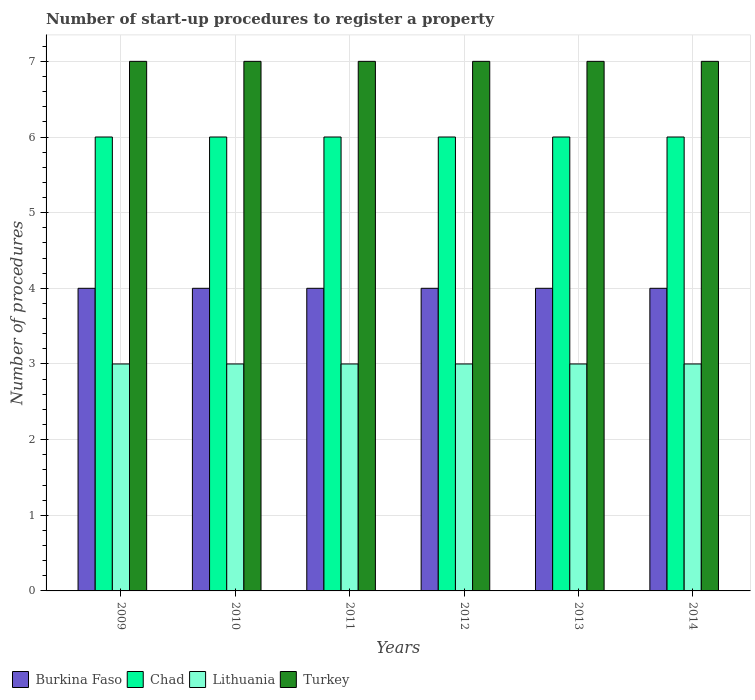How many different coloured bars are there?
Your answer should be very brief. 4. How many bars are there on the 4th tick from the left?
Ensure brevity in your answer.  4. What is the label of the 1st group of bars from the left?
Your answer should be very brief. 2009. What is the number of procedures required to register a property in Turkey in 2010?
Your answer should be very brief. 7. Across all years, what is the minimum number of procedures required to register a property in Lithuania?
Give a very brief answer. 3. What is the total number of procedures required to register a property in Lithuania in the graph?
Ensure brevity in your answer.  18. What is the difference between the number of procedures required to register a property in Turkey in 2011 and the number of procedures required to register a property in Lithuania in 2012?
Your answer should be compact. 4. In the year 2010, what is the difference between the number of procedures required to register a property in Turkey and number of procedures required to register a property in Lithuania?
Offer a terse response. 4. In how many years, is the number of procedures required to register a property in Burkina Faso greater than 5.6?
Your response must be concise. 0. Is the difference between the number of procedures required to register a property in Turkey in 2010 and 2011 greater than the difference between the number of procedures required to register a property in Lithuania in 2010 and 2011?
Your answer should be compact. No. What is the difference between the highest and the lowest number of procedures required to register a property in Lithuania?
Give a very brief answer. 0. Is the sum of the number of procedures required to register a property in Burkina Faso in 2009 and 2012 greater than the maximum number of procedures required to register a property in Chad across all years?
Provide a short and direct response. Yes. What does the 3rd bar from the left in 2009 represents?
Keep it short and to the point. Lithuania. What does the 4th bar from the right in 2012 represents?
Provide a succinct answer. Burkina Faso. Are all the bars in the graph horizontal?
Your answer should be very brief. No. How many years are there in the graph?
Provide a short and direct response. 6. What is the difference between two consecutive major ticks on the Y-axis?
Your answer should be very brief. 1. Does the graph contain any zero values?
Ensure brevity in your answer.  No. Does the graph contain grids?
Keep it short and to the point. Yes. How many legend labels are there?
Provide a short and direct response. 4. What is the title of the graph?
Provide a succinct answer. Number of start-up procedures to register a property. What is the label or title of the Y-axis?
Provide a succinct answer. Number of procedures. What is the Number of procedures in Burkina Faso in 2009?
Offer a very short reply. 4. What is the Number of procedures of Lithuania in 2009?
Your answer should be very brief. 3. What is the Number of procedures in Turkey in 2009?
Provide a short and direct response. 7. What is the Number of procedures in Burkina Faso in 2010?
Provide a succinct answer. 4. What is the Number of procedures of Chad in 2010?
Offer a very short reply. 6. What is the Number of procedures in Burkina Faso in 2011?
Offer a very short reply. 4. What is the Number of procedures of Lithuania in 2011?
Offer a very short reply. 3. What is the Number of procedures of Burkina Faso in 2012?
Your answer should be compact. 4. What is the Number of procedures of Turkey in 2012?
Offer a terse response. 7. What is the Number of procedures in Burkina Faso in 2014?
Make the answer very short. 4. What is the Number of procedures of Turkey in 2014?
Provide a short and direct response. 7. Across all years, what is the maximum Number of procedures in Lithuania?
Provide a succinct answer. 3. Across all years, what is the minimum Number of procedures of Burkina Faso?
Your response must be concise. 4. Across all years, what is the minimum Number of procedures of Lithuania?
Your answer should be very brief. 3. What is the total Number of procedures in Burkina Faso in the graph?
Provide a succinct answer. 24. What is the total Number of procedures of Chad in the graph?
Offer a very short reply. 36. What is the difference between the Number of procedures of Chad in 2009 and that in 2010?
Provide a short and direct response. 0. What is the difference between the Number of procedures of Burkina Faso in 2009 and that in 2011?
Give a very brief answer. 0. What is the difference between the Number of procedures in Chad in 2009 and that in 2011?
Offer a terse response. 0. What is the difference between the Number of procedures in Lithuania in 2009 and that in 2011?
Offer a terse response. 0. What is the difference between the Number of procedures in Turkey in 2009 and that in 2011?
Your answer should be very brief. 0. What is the difference between the Number of procedures in Lithuania in 2009 and that in 2012?
Your response must be concise. 0. What is the difference between the Number of procedures of Turkey in 2009 and that in 2012?
Keep it short and to the point. 0. What is the difference between the Number of procedures in Lithuania in 2009 and that in 2013?
Keep it short and to the point. 0. What is the difference between the Number of procedures of Turkey in 2009 and that in 2013?
Ensure brevity in your answer.  0. What is the difference between the Number of procedures of Burkina Faso in 2009 and that in 2014?
Offer a terse response. 0. What is the difference between the Number of procedures of Turkey in 2009 and that in 2014?
Keep it short and to the point. 0. What is the difference between the Number of procedures in Burkina Faso in 2010 and that in 2011?
Make the answer very short. 0. What is the difference between the Number of procedures of Lithuania in 2010 and that in 2011?
Your answer should be compact. 0. What is the difference between the Number of procedures of Lithuania in 2010 and that in 2012?
Ensure brevity in your answer.  0. What is the difference between the Number of procedures in Turkey in 2010 and that in 2012?
Your answer should be compact. 0. What is the difference between the Number of procedures in Chad in 2010 and that in 2013?
Provide a short and direct response. 0. What is the difference between the Number of procedures in Chad in 2010 and that in 2014?
Provide a succinct answer. 0. What is the difference between the Number of procedures in Lithuania in 2010 and that in 2014?
Offer a very short reply. 0. What is the difference between the Number of procedures in Chad in 2011 and that in 2012?
Ensure brevity in your answer.  0. What is the difference between the Number of procedures in Lithuania in 2011 and that in 2012?
Make the answer very short. 0. What is the difference between the Number of procedures in Turkey in 2011 and that in 2012?
Offer a terse response. 0. What is the difference between the Number of procedures in Chad in 2011 and that in 2013?
Make the answer very short. 0. What is the difference between the Number of procedures of Lithuania in 2011 and that in 2013?
Provide a succinct answer. 0. What is the difference between the Number of procedures of Turkey in 2011 and that in 2013?
Keep it short and to the point. 0. What is the difference between the Number of procedures of Turkey in 2011 and that in 2014?
Give a very brief answer. 0. What is the difference between the Number of procedures of Burkina Faso in 2012 and that in 2013?
Ensure brevity in your answer.  0. What is the difference between the Number of procedures in Turkey in 2012 and that in 2013?
Keep it short and to the point. 0. What is the difference between the Number of procedures of Burkina Faso in 2012 and that in 2014?
Your response must be concise. 0. What is the difference between the Number of procedures of Chad in 2012 and that in 2014?
Keep it short and to the point. 0. What is the difference between the Number of procedures in Lithuania in 2012 and that in 2014?
Provide a short and direct response. 0. What is the difference between the Number of procedures of Chad in 2013 and that in 2014?
Your answer should be very brief. 0. What is the difference between the Number of procedures of Burkina Faso in 2009 and the Number of procedures of Chad in 2010?
Your answer should be compact. -2. What is the difference between the Number of procedures of Burkina Faso in 2009 and the Number of procedures of Lithuania in 2010?
Your answer should be very brief. 1. What is the difference between the Number of procedures in Burkina Faso in 2009 and the Number of procedures in Turkey in 2010?
Give a very brief answer. -3. What is the difference between the Number of procedures in Chad in 2009 and the Number of procedures in Lithuania in 2010?
Keep it short and to the point. 3. What is the difference between the Number of procedures of Burkina Faso in 2009 and the Number of procedures of Lithuania in 2011?
Make the answer very short. 1. What is the difference between the Number of procedures in Burkina Faso in 2009 and the Number of procedures in Turkey in 2011?
Your response must be concise. -3. What is the difference between the Number of procedures of Chad in 2009 and the Number of procedures of Lithuania in 2011?
Offer a very short reply. 3. What is the difference between the Number of procedures of Chad in 2009 and the Number of procedures of Turkey in 2011?
Keep it short and to the point. -1. What is the difference between the Number of procedures of Lithuania in 2009 and the Number of procedures of Turkey in 2011?
Ensure brevity in your answer.  -4. What is the difference between the Number of procedures of Burkina Faso in 2009 and the Number of procedures of Chad in 2013?
Ensure brevity in your answer.  -2. What is the difference between the Number of procedures of Chad in 2009 and the Number of procedures of Turkey in 2013?
Keep it short and to the point. -1. What is the difference between the Number of procedures in Lithuania in 2009 and the Number of procedures in Turkey in 2013?
Provide a succinct answer. -4. What is the difference between the Number of procedures of Burkina Faso in 2009 and the Number of procedures of Chad in 2014?
Provide a short and direct response. -2. What is the difference between the Number of procedures of Burkina Faso in 2009 and the Number of procedures of Lithuania in 2014?
Your answer should be compact. 1. What is the difference between the Number of procedures of Burkina Faso in 2009 and the Number of procedures of Turkey in 2014?
Keep it short and to the point. -3. What is the difference between the Number of procedures of Chad in 2009 and the Number of procedures of Lithuania in 2014?
Your answer should be very brief. 3. What is the difference between the Number of procedures of Chad in 2009 and the Number of procedures of Turkey in 2014?
Your answer should be very brief. -1. What is the difference between the Number of procedures in Lithuania in 2009 and the Number of procedures in Turkey in 2014?
Offer a terse response. -4. What is the difference between the Number of procedures in Chad in 2010 and the Number of procedures in Lithuania in 2011?
Offer a terse response. 3. What is the difference between the Number of procedures of Burkina Faso in 2010 and the Number of procedures of Chad in 2012?
Offer a very short reply. -2. What is the difference between the Number of procedures in Burkina Faso in 2010 and the Number of procedures in Lithuania in 2012?
Your answer should be compact. 1. What is the difference between the Number of procedures in Burkina Faso in 2010 and the Number of procedures in Turkey in 2012?
Offer a very short reply. -3. What is the difference between the Number of procedures of Chad in 2010 and the Number of procedures of Turkey in 2012?
Make the answer very short. -1. What is the difference between the Number of procedures in Burkina Faso in 2010 and the Number of procedures in Chad in 2013?
Provide a short and direct response. -2. What is the difference between the Number of procedures in Lithuania in 2010 and the Number of procedures in Turkey in 2013?
Your response must be concise. -4. What is the difference between the Number of procedures in Burkina Faso in 2010 and the Number of procedures in Chad in 2014?
Give a very brief answer. -2. What is the difference between the Number of procedures in Burkina Faso in 2010 and the Number of procedures in Turkey in 2014?
Provide a short and direct response. -3. What is the difference between the Number of procedures in Chad in 2010 and the Number of procedures in Lithuania in 2014?
Your response must be concise. 3. What is the difference between the Number of procedures of Chad in 2010 and the Number of procedures of Turkey in 2014?
Offer a terse response. -1. What is the difference between the Number of procedures of Lithuania in 2010 and the Number of procedures of Turkey in 2014?
Provide a short and direct response. -4. What is the difference between the Number of procedures of Chad in 2011 and the Number of procedures of Lithuania in 2012?
Your answer should be compact. 3. What is the difference between the Number of procedures of Lithuania in 2011 and the Number of procedures of Turkey in 2012?
Ensure brevity in your answer.  -4. What is the difference between the Number of procedures in Burkina Faso in 2011 and the Number of procedures in Chad in 2013?
Offer a very short reply. -2. What is the difference between the Number of procedures of Burkina Faso in 2011 and the Number of procedures of Lithuania in 2013?
Ensure brevity in your answer.  1. What is the difference between the Number of procedures of Burkina Faso in 2011 and the Number of procedures of Turkey in 2013?
Offer a terse response. -3. What is the difference between the Number of procedures of Chad in 2011 and the Number of procedures of Turkey in 2013?
Your answer should be very brief. -1. What is the difference between the Number of procedures of Burkina Faso in 2011 and the Number of procedures of Lithuania in 2014?
Your response must be concise. 1. What is the difference between the Number of procedures of Chad in 2011 and the Number of procedures of Turkey in 2014?
Your answer should be compact. -1. What is the difference between the Number of procedures of Lithuania in 2011 and the Number of procedures of Turkey in 2014?
Make the answer very short. -4. What is the difference between the Number of procedures in Burkina Faso in 2012 and the Number of procedures in Chad in 2013?
Give a very brief answer. -2. What is the difference between the Number of procedures of Burkina Faso in 2012 and the Number of procedures of Turkey in 2013?
Ensure brevity in your answer.  -3. What is the difference between the Number of procedures of Chad in 2012 and the Number of procedures of Lithuania in 2013?
Offer a terse response. 3. What is the difference between the Number of procedures in Chad in 2012 and the Number of procedures in Turkey in 2013?
Provide a short and direct response. -1. What is the difference between the Number of procedures in Lithuania in 2012 and the Number of procedures in Turkey in 2013?
Ensure brevity in your answer.  -4. What is the difference between the Number of procedures in Burkina Faso in 2012 and the Number of procedures in Lithuania in 2014?
Your response must be concise. 1. What is the difference between the Number of procedures in Burkina Faso in 2012 and the Number of procedures in Turkey in 2014?
Your answer should be very brief. -3. What is the difference between the Number of procedures in Lithuania in 2012 and the Number of procedures in Turkey in 2014?
Your answer should be compact. -4. What is the difference between the Number of procedures of Burkina Faso in 2013 and the Number of procedures of Chad in 2014?
Provide a short and direct response. -2. What is the difference between the Number of procedures of Burkina Faso in 2013 and the Number of procedures of Lithuania in 2014?
Provide a succinct answer. 1. What is the difference between the Number of procedures in Chad in 2013 and the Number of procedures in Lithuania in 2014?
Give a very brief answer. 3. What is the difference between the Number of procedures in Lithuania in 2013 and the Number of procedures in Turkey in 2014?
Your response must be concise. -4. What is the average Number of procedures of Burkina Faso per year?
Offer a terse response. 4. What is the average Number of procedures of Chad per year?
Give a very brief answer. 6. What is the average Number of procedures of Lithuania per year?
Give a very brief answer. 3. In the year 2009, what is the difference between the Number of procedures of Burkina Faso and Number of procedures of Lithuania?
Offer a terse response. 1. In the year 2009, what is the difference between the Number of procedures of Burkina Faso and Number of procedures of Turkey?
Keep it short and to the point. -3. In the year 2009, what is the difference between the Number of procedures in Chad and Number of procedures in Lithuania?
Keep it short and to the point. 3. In the year 2010, what is the difference between the Number of procedures of Burkina Faso and Number of procedures of Chad?
Give a very brief answer. -2. In the year 2010, what is the difference between the Number of procedures in Chad and Number of procedures in Turkey?
Make the answer very short. -1. In the year 2011, what is the difference between the Number of procedures in Burkina Faso and Number of procedures in Lithuania?
Keep it short and to the point. 1. In the year 2011, what is the difference between the Number of procedures of Chad and Number of procedures of Turkey?
Give a very brief answer. -1. In the year 2011, what is the difference between the Number of procedures in Lithuania and Number of procedures in Turkey?
Provide a short and direct response. -4. In the year 2012, what is the difference between the Number of procedures of Burkina Faso and Number of procedures of Chad?
Your answer should be compact. -2. In the year 2012, what is the difference between the Number of procedures in Burkina Faso and Number of procedures in Lithuania?
Give a very brief answer. 1. In the year 2012, what is the difference between the Number of procedures in Burkina Faso and Number of procedures in Turkey?
Offer a terse response. -3. In the year 2012, what is the difference between the Number of procedures of Chad and Number of procedures of Lithuania?
Offer a terse response. 3. In the year 2012, what is the difference between the Number of procedures in Chad and Number of procedures in Turkey?
Give a very brief answer. -1. In the year 2012, what is the difference between the Number of procedures in Lithuania and Number of procedures in Turkey?
Offer a terse response. -4. In the year 2013, what is the difference between the Number of procedures of Burkina Faso and Number of procedures of Lithuania?
Your answer should be very brief. 1. In the year 2013, what is the difference between the Number of procedures of Lithuania and Number of procedures of Turkey?
Ensure brevity in your answer.  -4. In the year 2014, what is the difference between the Number of procedures of Burkina Faso and Number of procedures of Chad?
Keep it short and to the point. -2. In the year 2014, what is the difference between the Number of procedures of Burkina Faso and Number of procedures of Lithuania?
Provide a short and direct response. 1. In the year 2014, what is the difference between the Number of procedures in Burkina Faso and Number of procedures in Turkey?
Your response must be concise. -3. In the year 2014, what is the difference between the Number of procedures in Lithuania and Number of procedures in Turkey?
Make the answer very short. -4. What is the ratio of the Number of procedures in Chad in 2009 to that in 2010?
Your answer should be very brief. 1. What is the ratio of the Number of procedures of Lithuania in 2009 to that in 2011?
Your response must be concise. 1. What is the ratio of the Number of procedures in Turkey in 2009 to that in 2011?
Your answer should be very brief. 1. What is the ratio of the Number of procedures of Burkina Faso in 2009 to that in 2012?
Ensure brevity in your answer.  1. What is the ratio of the Number of procedures in Chad in 2009 to that in 2012?
Keep it short and to the point. 1. What is the ratio of the Number of procedures of Lithuania in 2009 to that in 2012?
Your response must be concise. 1. What is the ratio of the Number of procedures in Chad in 2009 to that in 2013?
Your answer should be very brief. 1. What is the ratio of the Number of procedures in Lithuania in 2009 to that in 2013?
Offer a very short reply. 1. What is the ratio of the Number of procedures in Turkey in 2009 to that in 2013?
Make the answer very short. 1. What is the ratio of the Number of procedures of Burkina Faso in 2009 to that in 2014?
Make the answer very short. 1. What is the ratio of the Number of procedures in Lithuania in 2009 to that in 2014?
Your answer should be compact. 1. What is the ratio of the Number of procedures of Turkey in 2009 to that in 2014?
Your response must be concise. 1. What is the ratio of the Number of procedures in Chad in 2010 to that in 2011?
Provide a short and direct response. 1. What is the ratio of the Number of procedures in Chad in 2010 to that in 2012?
Give a very brief answer. 1. What is the ratio of the Number of procedures of Turkey in 2010 to that in 2012?
Your response must be concise. 1. What is the ratio of the Number of procedures of Chad in 2010 to that in 2013?
Your answer should be compact. 1. What is the ratio of the Number of procedures in Turkey in 2010 to that in 2013?
Ensure brevity in your answer.  1. What is the ratio of the Number of procedures in Burkina Faso in 2010 to that in 2014?
Ensure brevity in your answer.  1. What is the ratio of the Number of procedures in Lithuania in 2010 to that in 2014?
Your answer should be compact. 1. What is the ratio of the Number of procedures in Turkey in 2010 to that in 2014?
Your response must be concise. 1. What is the ratio of the Number of procedures in Burkina Faso in 2011 to that in 2012?
Make the answer very short. 1. What is the ratio of the Number of procedures of Chad in 2011 to that in 2012?
Offer a very short reply. 1. What is the ratio of the Number of procedures in Turkey in 2011 to that in 2012?
Make the answer very short. 1. What is the ratio of the Number of procedures in Chad in 2011 to that in 2013?
Make the answer very short. 1. What is the ratio of the Number of procedures in Turkey in 2011 to that in 2013?
Make the answer very short. 1. What is the ratio of the Number of procedures in Chad in 2011 to that in 2014?
Your answer should be very brief. 1. What is the ratio of the Number of procedures of Turkey in 2011 to that in 2014?
Make the answer very short. 1. What is the ratio of the Number of procedures in Burkina Faso in 2012 to that in 2013?
Offer a terse response. 1. What is the ratio of the Number of procedures in Chad in 2012 to that in 2013?
Keep it short and to the point. 1. What is the ratio of the Number of procedures of Lithuania in 2012 to that in 2013?
Offer a very short reply. 1. What is the ratio of the Number of procedures of Turkey in 2012 to that in 2013?
Ensure brevity in your answer.  1. What is the ratio of the Number of procedures of Chad in 2012 to that in 2014?
Ensure brevity in your answer.  1. What is the ratio of the Number of procedures of Lithuania in 2012 to that in 2014?
Give a very brief answer. 1. What is the ratio of the Number of procedures of Burkina Faso in 2013 to that in 2014?
Keep it short and to the point. 1. What is the ratio of the Number of procedures of Lithuania in 2013 to that in 2014?
Ensure brevity in your answer.  1. What is the ratio of the Number of procedures in Turkey in 2013 to that in 2014?
Keep it short and to the point. 1. What is the difference between the highest and the second highest Number of procedures in Burkina Faso?
Offer a very short reply. 0. What is the difference between the highest and the second highest Number of procedures of Chad?
Offer a very short reply. 0. What is the difference between the highest and the second highest Number of procedures in Lithuania?
Offer a terse response. 0. What is the difference between the highest and the lowest Number of procedures in Chad?
Ensure brevity in your answer.  0. 